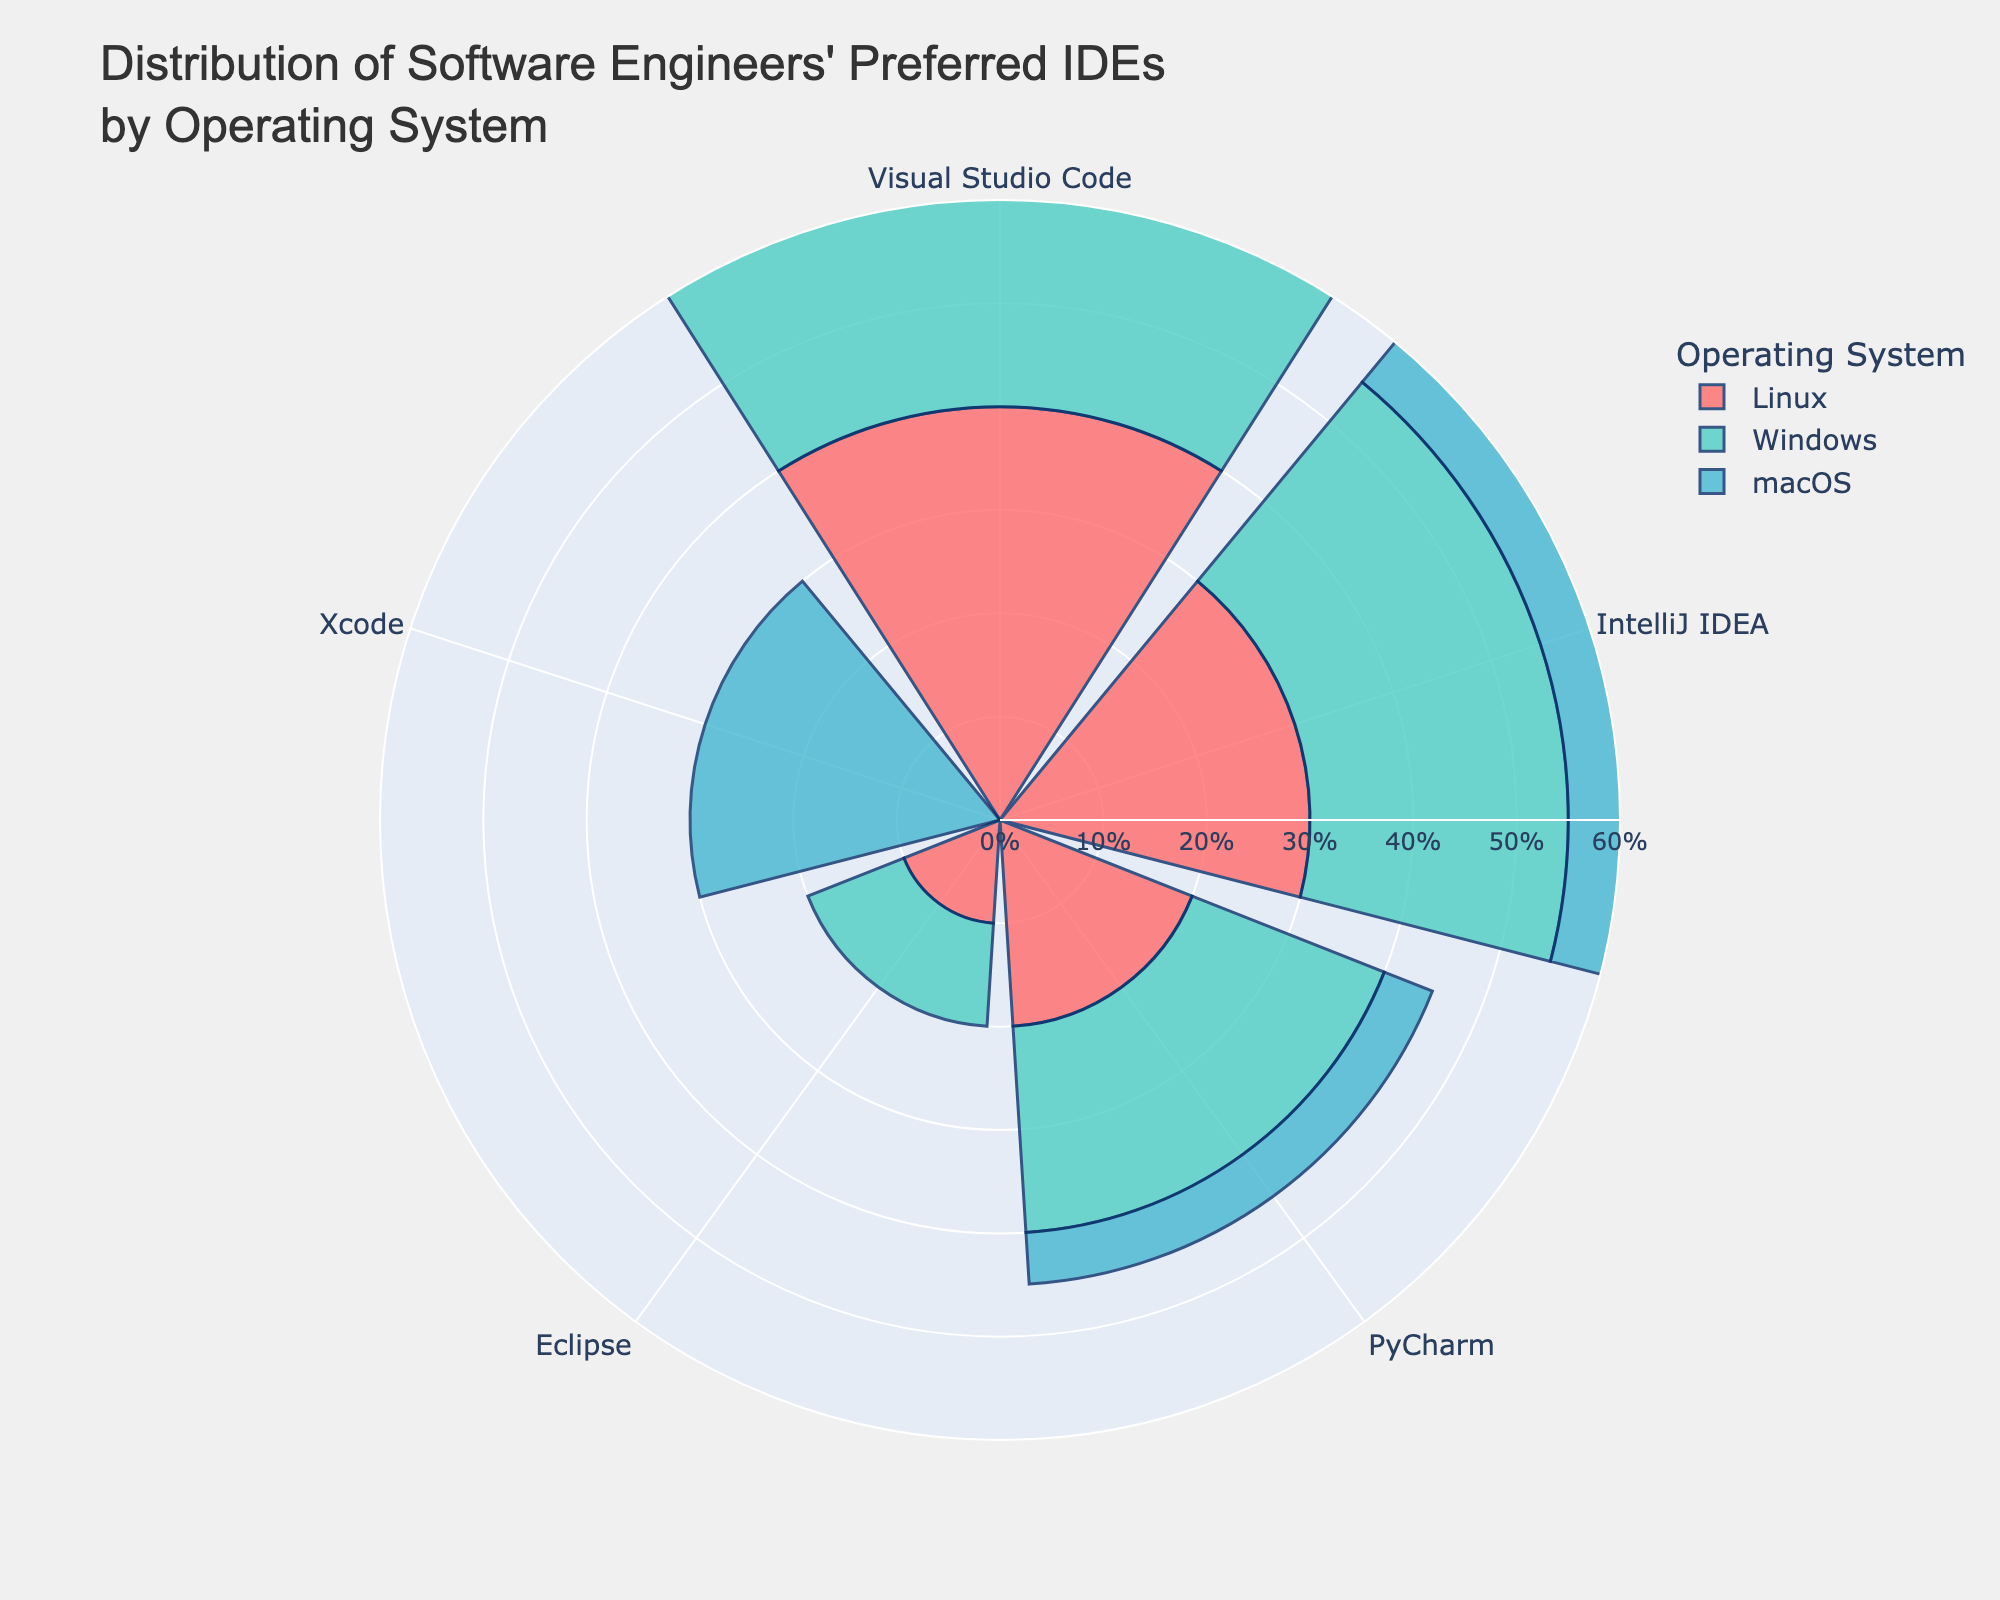What are the top two preferred IDEs for Windows users? Looking at the figure, under Windows, Visual Studio Code has the highest percentage, followed by IntelliJ IDEA.
Answer: Visual Studio Code, IntelliJ IDEA Which operating system has the highest percentage of Xcode users? Examine the chart for Xcode across different operating systems. Only macOS has Xcode listed, with 30%.
Answer: macOS How does the preference for PyCharm on macOS compare to that on Linux? On macOS, PyCharm is preferred by 5% of users, whereas on Linux it is preferred by 20% of users.
Answer: 5% on macOS, 20% on Linux Which IDE has the highest variability in usage across different operating systems? Visual Studio Code is the highest and most consistently used IDE across all operating systems, with percentages varying from 40% to 50%.
Answer: Visual Studio Code What percentage of Linux users prefer IntelliJ IDEA? Check the corresponding bar for IntelliJ IDEA under the Linux section, which shows 30%.
Answer: 30% Which operating system has the least percentage of Visual Studio Code users? Compare the percentages of Visual Studio Code across all operating systems. Linux has the least at 40%.
Answer: Linux What is the combined percentage of Eclipse users across all operating systems? Sum the Eclipse usage percentages: Windows (10%) + Linux (10%) = 20%. macOS does not use Eclipse.
Answer: 20% Is there any IDE exclusively used by one operating system? Review the IDEs listed for each operating system. Xcode is the only IDE exclusive to macOS.
Answer: Xcode What's the average percentage of PyCharm users across all operating systems? Add up the percentages for PyCharm: Windows (20%) + macOS (5%) + Linux (20%) = 45%. Divide by 3, the number of operating systems: 45% / 3 = 15%.
Answer: 15% For Windows, what is the difference in preference percentage between Visual Studio Code and Eclipse? Subtract the percentage of Eclipse users from Visual Studio Code users on Windows: 45% - 10% = 35%.
Answer: 35% 